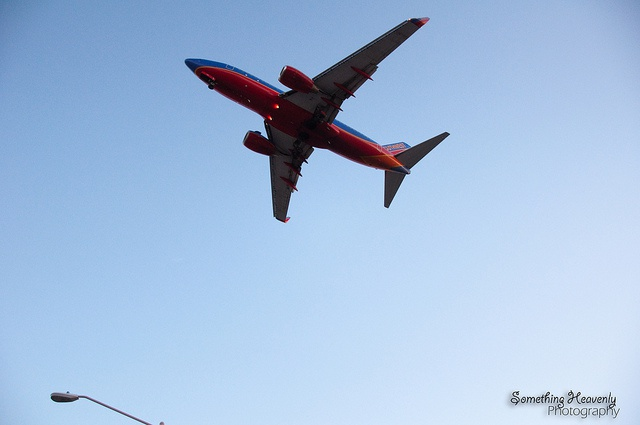Describe the objects in this image and their specific colors. I can see a airplane in gray, black, maroon, and blue tones in this image. 